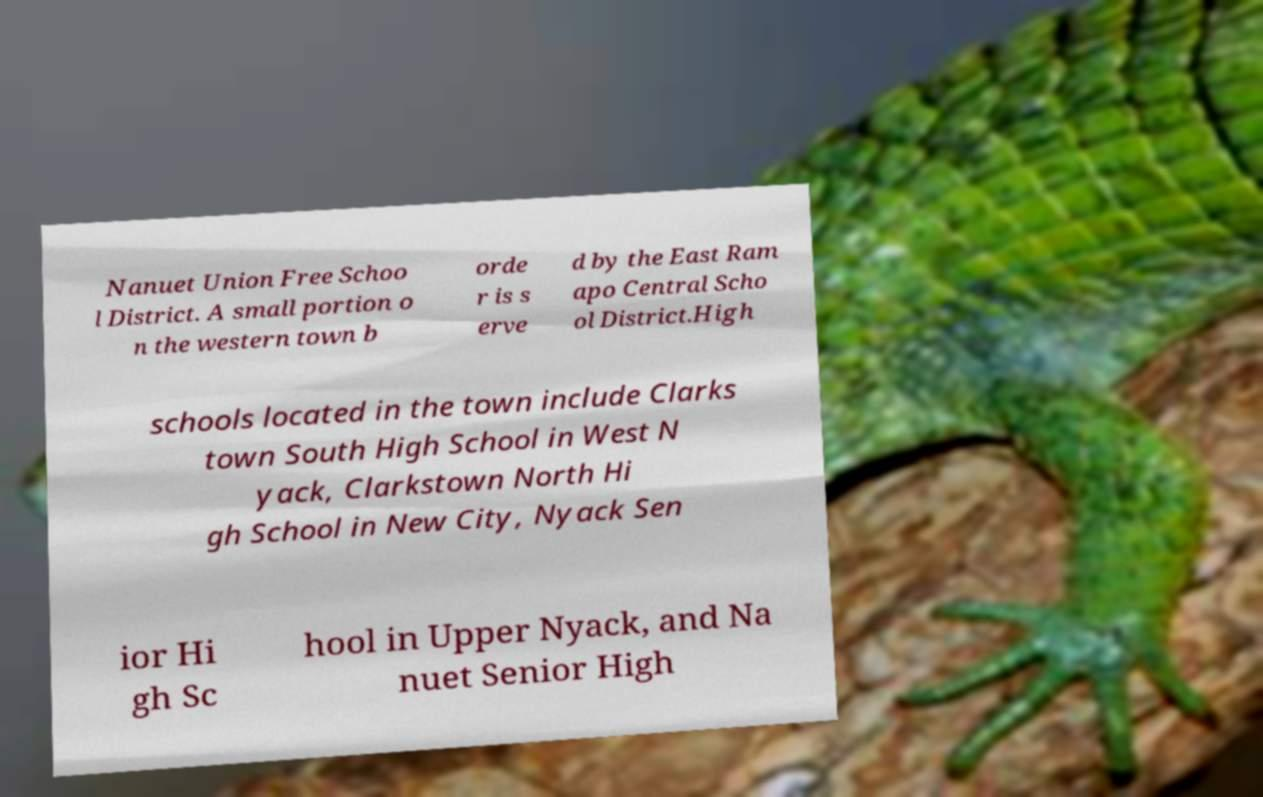Can you read and provide the text displayed in the image?This photo seems to have some interesting text. Can you extract and type it out for me? Nanuet Union Free Schoo l District. A small portion o n the western town b orde r is s erve d by the East Ram apo Central Scho ol District.High schools located in the town include Clarks town South High School in West N yack, Clarkstown North Hi gh School in New City, Nyack Sen ior Hi gh Sc hool in Upper Nyack, and Na nuet Senior High 